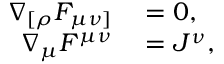<formula> <loc_0><loc_0><loc_500><loc_500>\begin{array} { r l } { \nabla _ { [ \rho } F _ { \mu \nu ] } } & = 0 , } \\ { \nabla _ { \mu } F ^ { \mu \nu } } & = J ^ { \nu } , } \end{array}</formula> 